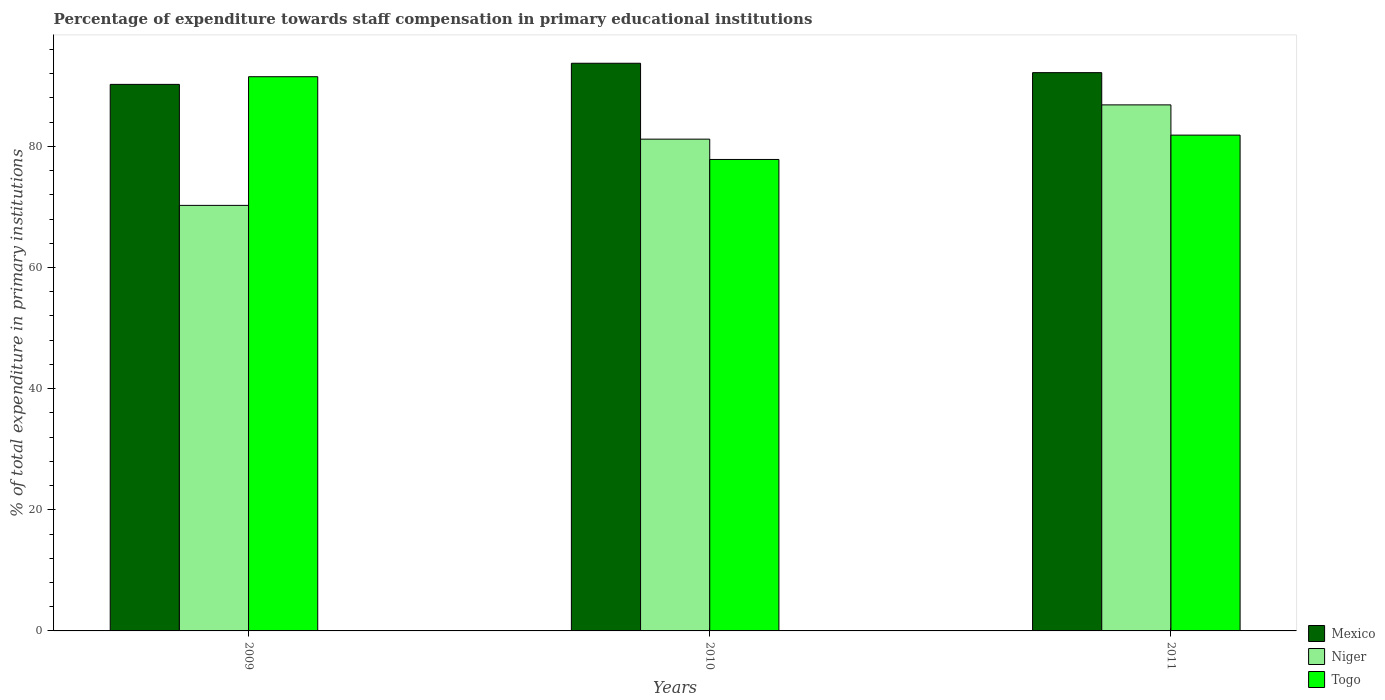How many different coloured bars are there?
Keep it short and to the point. 3. Are the number of bars on each tick of the X-axis equal?
Your answer should be very brief. Yes. What is the percentage of expenditure towards staff compensation in Mexico in 2010?
Offer a terse response. 93.73. Across all years, what is the maximum percentage of expenditure towards staff compensation in Niger?
Make the answer very short. 86.86. Across all years, what is the minimum percentage of expenditure towards staff compensation in Mexico?
Make the answer very short. 90.24. In which year was the percentage of expenditure towards staff compensation in Niger maximum?
Your answer should be very brief. 2011. In which year was the percentage of expenditure towards staff compensation in Niger minimum?
Offer a very short reply. 2009. What is the total percentage of expenditure towards staff compensation in Togo in the graph?
Your answer should be very brief. 251.22. What is the difference between the percentage of expenditure towards staff compensation in Mexico in 2010 and that in 2011?
Give a very brief answer. 1.55. What is the difference between the percentage of expenditure towards staff compensation in Mexico in 2010 and the percentage of expenditure towards staff compensation in Togo in 2009?
Offer a terse response. 2.22. What is the average percentage of expenditure towards staff compensation in Niger per year?
Provide a short and direct response. 79.44. In the year 2009, what is the difference between the percentage of expenditure towards staff compensation in Togo and percentage of expenditure towards staff compensation in Mexico?
Make the answer very short. 1.27. What is the ratio of the percentage of expenditure towards staff compensation in Niger in 2010 to that in 2011?
Provide a short and direct response. 0.93. What is the difference between the highest and the second highest percentage of expenditure towards staff compensation in Mexico?
Provide a short and direct response. 1.55. What is the difference between the highest and the lowest percentage of expenditure towards staff compensation in Togo?
Offer a terse response. 13.66. Is the sum of the percentage of expenditure towards staff compensation in Mexico in 2010 and 2011 greater than the maximum percentage of expenditure towards staff compensation in Niger across all years?
Ensure brevity in your answer.  Yes. What does the 1st bar from the left in 2009 represents?
Offer a terse response. Mexico. What does the 2nd bar from the right in 2009 represents?
Give a very brief answer. Niger. Is it the case that in every year, the sum of the percentage of expenditure towards staff compensation in Mexico and percentage of expenditure towards staff compensation in Niger is greater than the percentage of expenditure towards staff compensation in Togo?
Provide a short and direct response. Yes. How many bars are there?
Make the answer very short. 9. Are all the bars in the graph horizontal?
Provide a succinct answer. No. How many years are there in the graph?
Your response must be concise. 3. What is the difference between two consecutive major ticks on the Y-axis?
Keep it short and to the point. 20. Does the graph contain any zero values?
Your response must be concise. No. Where does the legend appear in the graph?
Make the answer very short. Bottom right. How are the legend labels stacked?
Your answer should be very brief. Vertical. What is the title of the graph?
Your answer should be compact. Percentage of expenditure towards staff compensation in primary educational institutions. What is the label or title of the X-axis?
Give a very brief answer. Years. What is the label or title of the Y-axis?
Offer a very short reply. % of total expenditure in primary institutions. What is the % of total expenditure in primary institutions in Mexico in 2009?
Your answer should be compact. 90.24. What is the % of total expenditure in primary institutions in Niger in 2009?
Give a very brief answer. 70.26. What is the % of total expenditure in primary institutions in Togo in 2009?
Your answer should be very brief. 91.51. What is the % of total expenditure in primary institutions of Mexico in 2010?
Provide a succinct answer. 93.73. What is the % of total expenditure in primary institutions of Niger in 2010?
Your response must be concise. 81.2. What is the % of total expenditure in primary institutions of Togo in 2010?
Offer a terse response. 77.85. What is the % of total expenditure in primary institutions of Mexico in 2011?
Offer a terse response. 92.18. What is the % of total expenditure in primary institutions of Niger in 2011?
Give a very brief answer. 86.86. What is the % of total expenditure in primary institutions in Togo in 2011?
Provide a succinct answer. 81.87. Across all years, what is the maximum % of total expenditure in primary institutions in Mexico?
Provide a succinct answer. 93.73. Across all years, what is the maximum % of total expenditure in primary institutions in Niger?
Offer a terse response. 86.86. Across all years, what is the maximum % of total expenditure in primary institutions in Togo?
Offer a very short reply. 91.51. Across all years, what is the minimum % of total expenditure in primary institutions of Mexico?
Provide a succinct answer. 90.24. Across all years, what is the minimum % of total expenditure in primary institutions in Niger?
Keep it short and to the point. 70.26. Across all years, what is the minimum % of total expenditure in primary institutions of Togo?
Ensure brevity in your answer.  77.85. What is the total % of total expenditure in primary institutions in Mexico in the graph?
Ensure brevity in your answer.  276.15. What is the total % of total expenditure in primary institutions in Niger in the graph?
Provide a short and direct response. 238.32. What is the total % of total expenditure in primary institutions of Togo in the graph?
Ensure brevity in your answer.  251.22. What is the difference between the % of total expenditure in primary institutions of Mexico in 2009 and that in 2010?
Give a very brief answer. -3.49. What is the difference between the % of total expenditure in primary institutions of Niger in 2009 and that in 2010?
Offer a very short reply. -10.94. What is the difference between the % of total expenditure in primary institutions of Togo in 2009 and that in 2010?
Your answer should be very brief. 13.66. What is the difference between the % of total expenditure in primary institutions in Mexico in 2009 and that in 2011?
Your response must be concise. -1.94. What is the difference between the % of total expenditure in primary institutions in Niger in 2009 and that in 2011?
Provide a short and direct response. -16.59. What is the difference between the % of total expenditure in primary institutions in Togo in 2009 and that in 2011?
Offer a terse response. 9.64. What is the difference between the % of total expenditure in primary institutions in Mexico in 2010 and that in 2011?
Give a very brief answer. 1.55. What is the difference between the % of total expenditure in primary institutions of Niger in 2010 and that in 2011?
Give a very brief answer. -5.66. What is the difference between the % of total expenditure in primary institutions in Togo in 2010 and that in 2011?
Provide a short and direct response. -4.02. What is the difference between the % of total expenditure in primary institutions of Mexico in 2009 and the % of total expenditure in primary institutions of Niger in 2010?
Keep it short and to the point. 9.04. What is the difference between the % of total expenditure in primary institutions in Mexico in 2009 and the % of total expenditure in primary institutions in Togo in 2010?
Make the answer very short. 12.4. What is the difference between the % of total expenditure in primary institutions of Niger in 2009 and the % of total expenditure in primary institutions of Togo in 2010?
Make the answer very short. -7.58. What is the difference between the % of total expenditure in primary institutions in Mexico in 2009 and the % of total expenditure in primary institutions in Niger in 2011?
Your response must be concise. 3.39. What is the difference between the % of total expenditure in primary institutions of Mexico in 2009 and the % of total expenditure in primary institutions of Togo in 2011?
Your answer should be compact. 8.38. What is the difference between the % of total expenditure in primary institutions of Niger in 2009 and the % of total expenditure in primary institutions of Togo in 2011?
Provide a short and direct response. -11.6. What is the difference between the % of total expenditure in primary institutions of Mexico in 2010 and the % of total expenditure in primary institutions of Niger in 2011?
Offer a terse response. 6.87. What is the difference between the % of total expenditure in primary institutions of Mexico in 2010 and the % of total expenditure in primary institutions of Togo in 2011?
Keep it short and to the point. 11.87. What is the difference between the % of total expenditure in primary institutions of Niger in 2010 and the % of total expenditure in primary institutions of Togo in 2011?
Provide a succinct answer. -0.67. What is the average % of total expenditure in primary institutions of Mexico per year?
Ensure brevity in your answer.  92.05. What is the average % of total expenditure in primary institutions of Niger per year?
Make the answer very short. 79.44. What is the average % of total expenditure in primary institutions of Togo per year?
Provide a short and direct response. 83.74. In the year 2009, what is the difference between the % of total expenditure in primary institutions in Mexico and % of total expenditure in primary institutions in Niger?
Offer a terse response. 19.98. In the year 2009, what is the difference between the % of total expenditure in primary institutions in Mexico and % of total expenditure in primary institutions in Togo?
Provide a short and direct response. -1.27. In the year 2009, what is the difference between the % of total expenditure in primary institutions of Niger and % of total expenditure in primary institutions of Togo?
Keep it short and to the point. -21.25. In the year 2010, what is the difference between the % of total expenditure in primary institutions of Mexico and % of total expenditure in primary institutions of Niger?
Your answer should be compact. 12.53. In the year 2010, what is the difference between the % of total expenditure in primary institutions in Mexico and % of total expenditure in primary institutions in Togo?
Offer a very short reply. 15.89. In the year 2010, what is the difference between the % of total expenditure in primary institutions in Niger and % of total expenditure in primary institutions in Togo?
Offer a very short reply. 3.35. In the year 2011, what is the difference between the % of total expenditure in primary institutions in Mexico and % of total expenditure in primary institutions in Niger?
Your answer should be compact. 5.32. In the year 2011, what is the difference between the % of total expenditure in primary institutions of Mexico and % of total expenditure in primary institutions of Togo?
Your answer should be compact. 10.31. In the year 2011, what is the difference between the % of total expenditure in primary institutions of Niger and % of total expenditure in primary institutions of Togo?
Give a very brief answer. 4.99. What is the ratio of the % of total expenditure in primary institutions of Mexico in 2009 to that in 2010?
Your answer should be compact. 0.96. What is the ratio of the % of total expenditure in primary institutions of Niger in 2009 to that in 2010?
Make the answer very short. 0.87. What is the ratio of the % of total expenditure in primary institutions of Togo in 2009 to that in 2010?
Your answer should be very brief. 1.18. What is the ratio of the % of total expenditure in primary institutions in Niger in 2009 to that in 2011?
Provide a short and direct response. 0.81. What is the ratio of the % of total expenditure in primary institutions of Togo in 2009 to that in 2011?
Keep it short and to the point. 1.12. What is the ratio of the % of total expenditure in primary institutions in Mexico in 2010 to that in 2011?
Your answer should be compact. 1.02. What is the ratio of the % of total expenditure in primary institutions of Niger in 2010 to that in 2011?
Provide a short and direct response. 0.93. What is the ratio of the % of total expenditure in primary institutions in Togo in 2010 to that in 2011?
Your answer should be compact. 0.95. What is the difference between the highest and the second highest % of total expenditure in primary institutions in Mexico?
Your answer should be very brief. 1.55. What is the difference between the highest and the second highest % of total expenditure in primary institutions in Niger?
Your response must be concise. 5.66. What is the difference between the highest and the second highest % of total expenditure in primary institutions of Togo?
Your answer should be compact. 9.64. What is the difference between the highest and the lowest % of total expenditure in primary institutions of Mexico?
Your response must be concise. 3.49. What is the difference between the highest and the lowest % of total expenditure in primary institutions of Niger?
Make the answer very short. 16.59. What is the difference between the highest and the lowest % of total expenditure in primary institutions in Togo?
Your response must be concise. 13.66. 